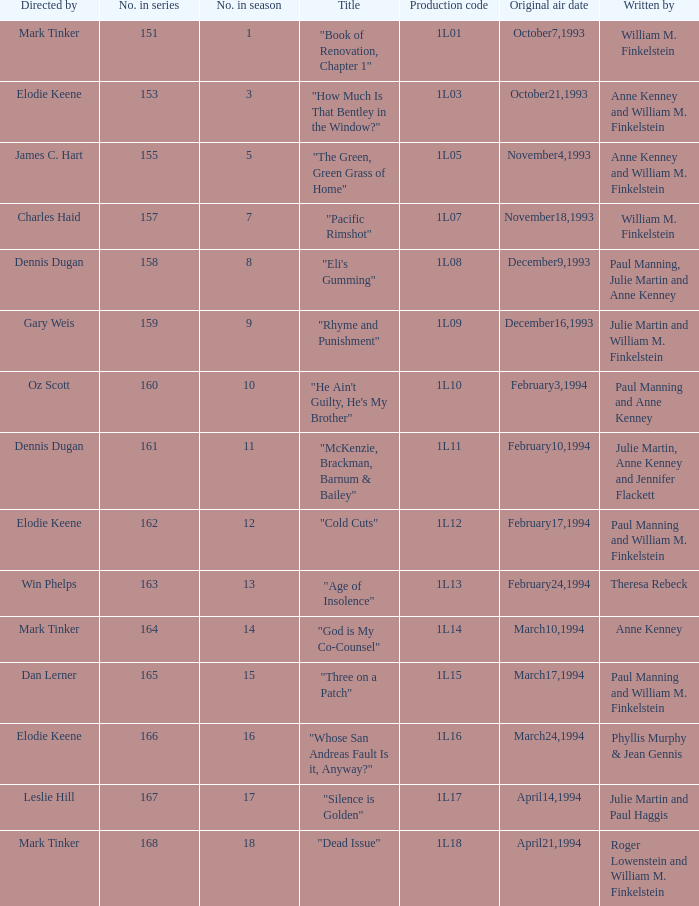Name who directed the production code 1l10 Oz Scott. 